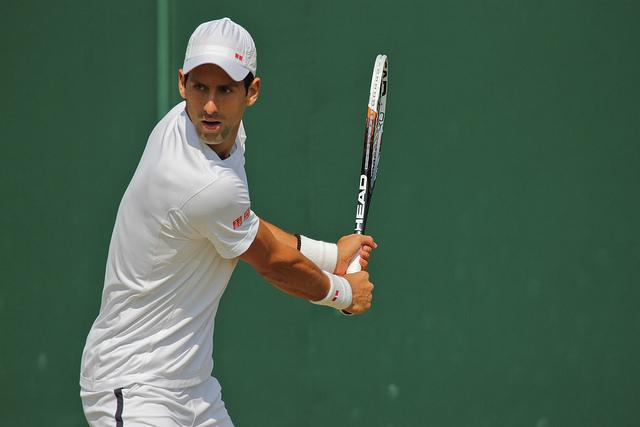Is this man ready to hit the tennis ball?
Answer briefly. Yes. What kind of hat does he have on?
Write a very short answer. Baseball cap. How is the man dressed?
Quick response, please. In white. How many wristbands does the man have on?
Concise answer only. 2. Is he being silly?
Give a very brief answer. No. 